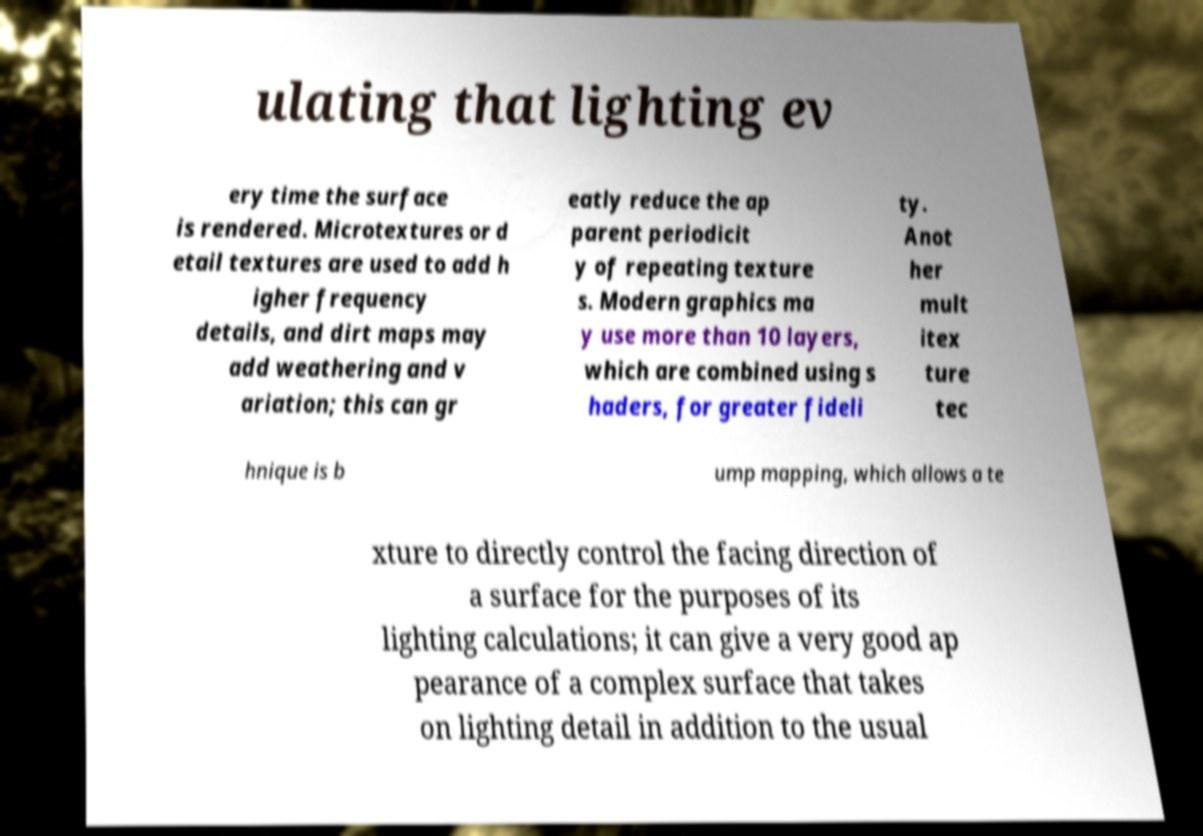There's text embedded in this image that I need extracted. Can you transcribe it verbatim? ulating that lighting ev ery time the surface is rendered. Microtextures or d etail textures are used to add h igher frequency details, and dirt maps may add weathering and v ariation; this can gr eatly reduce the ap parent periodicit y of repeating texture s. Modern graphics ma y use more than 10 layers, which are combined using s haders, for greater fideli ty. Anot her mult itex ture tec hnique is b ump mapping, which allows a te xture to directly control the facing direction of a surface for the purposes of its lighting calculations; it can give a very good ap pearance of a complex surface that takes on lighting detail in addition to the usual 